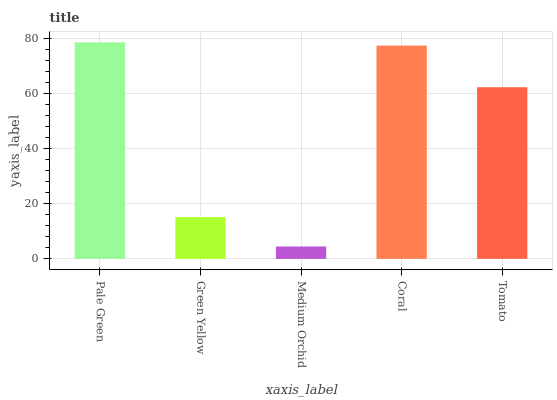Is Medium Orchid the minimum?
Answer yes or no. Yes. Is Pale Green the maximum?
Answer yes or no. Yes. Is Green Yellow the minimum?
Answer yes or no. No. Is Green Yellow the maximum?
Answer yes or no. No. Is Pale Green greater than Green Yellow?
Answer yes or no. Yes. Is Green Yellow less than Pale Green?
Answer yes or no. Yes. Is Green Yellow greater than Pale Green?
Answer yes or no. No. Is Pale Green less than Green Yellow?
Answer yes or no. No. Is Tomato the high median?
Answer yes or no. Yes. Is Tomato the low median?
Answer yes or no. Yes. Is Pale Green the high median?
Answer yes or no. No. Is Coral the low median?
Answer yes or no. No. 